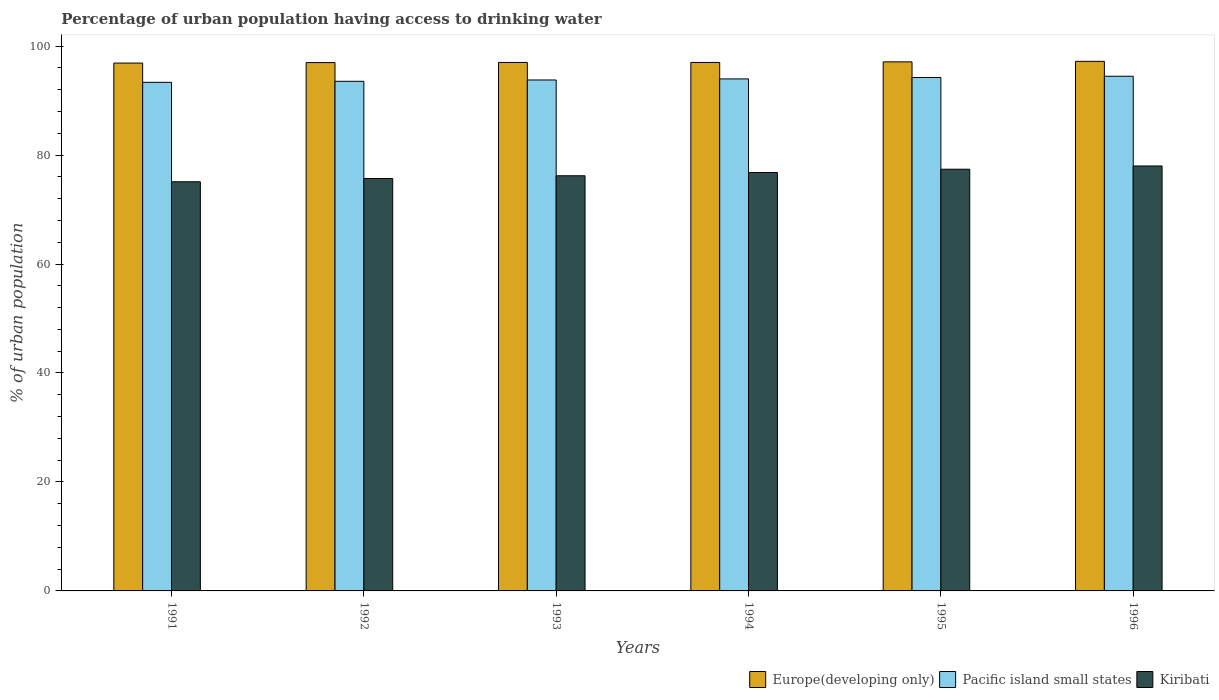How many bars are there on the 3rd tick from the left?
Give a very brief answer. 3. How many bars are there on the 1st tick from the right?
Your answer should be very brief. 3. What is the label of the 6th group of bars from the left?
Keep it short and to the point. 1996. What is the percentage of urban population having access to drinking water in Europe(developing only) in 1991?
Your response must be concise. 96.88. Across all years, what is the maximum percentage of urban population having access to drinking water in Pacific island small states?
Make the answer very short. 94.47. Across all years, what is the minimum percentage of urban population having access to drinking water in Kiribati?
Make the answer very short. 75.1. In which year was the percentage of urban population having access to drinking water in Europe(developing only) maximum?
Provide a succinct answer. 1996. What is the total percentage of urban population having access to drinking water in Europe(developing only) in the graph?
Your answer should be compact. 582.17. What is the difference between the percentage of urban population having access to drinking water in Pacific island small states in 1991 and that in 1995?
Your response must be concise. -0.89. What is the difference between the percentage of urban population having access to drinking water in Europe(developing only) in 1993 and the percentage of urban population having access to drinking water in Pacific island small states in 1994?
Ensure brevity in your answer.  3.02. What is the average percentage of urban population having access to drinking water in Europe(developing only) per year?
Provide a short and direct response. 97.03. In the year 1993, what is the difference between the percentage of urban population having access to drinking water in Kiribati and percentage of urban population having access to drinking water in Pacific island small states?
Offer a very short reply. -17.58. In how many years, is the percentage of urban population having access to drinking water in Kiribati greater than 68 %?
Your answer should be very brief. 6. What is the ratio of the percentage of urban population having access to drinking water in Kiribati in 1995 to that in 1996?
Provide a succinct answer. 0.99. Is the percentage of urban population having access to drinking water in Pacific island small states in 1991 less than that in 1992?
Your response must be concise. Yes. What is the difference between the highest and the second highest percentage of urban population having access to drinking water in Europe(developing only)?
Provide a short and direct response. 0.09. What is the difference between the highest and the lowest percentage of urban population having access to drinking water in Kiribati?
Make the answer very short. 2.9. In how many years, is the percentage of urban population having access to drinking water in Europe(developing only) greater than the average percentage of urban population having access to drinking water in Europe(developing only) taken over all years?
Give a very brief answer. 2. What does the 3rd bar from the left in 1995 represents?
Your response must be concise. Kiribati. What does the 2nd bar from the right in 1996 represents?
Offer a very short reply. Pacific island small states. Is it the case that in every year, the sum of the percentage of urban population having access to drinking water in Europe(developing only) and percentage of urban population having access to drinking water in Kiribati is greater than the percentage of urban population having access to drinking water in Pacific island small states?
Give a very brief answer. Yes. Are all the bars in the graph horizontal?
Your answer should be compact. No. How many years are there in the graph?
Give a very brief answer. 6. Are the values on the major ticks of Y-axis written in scientific E-notation?
Keep it short and to the point. No. Does the graph contain any zero values?
Your response must be concise. No. Where does the legend appear in the graph?
Your answer should be very brief. Bottom right. What is the title of the graph?
Offer a very short reply. Percentage of urban population having access to drinking water. What is the label or title of the X-axis?
Make the answer very short. Years. What is the label or title of the Y-axis?
Keep it short and to the point. % of urban population. What is the % of urban population in Europe(developing only) in 1991?
Your answer should be compact. 96.88. What is the % of urban population of Pacific island small states in 1991?
Offer a very short reply. 93.35. What is the % of urban population in Kiribati in 1991?
Provide a short and direct response. 75.1. What is the % of urban population of Europe(developing only) in 1992?
Keep it short and to the point. 96.97. What is the % of urban population of Pacific island small states in 1992?
Offer a terse response. 93.54. What is the % of urban population in Kiribati in 1992?
Offer a terse response. 75.7. What is the % of urban population of Europe(developing only) in 1993?
Your answer should be very brief. 97. What is the % of urban population in Pacific island small states in 1993?
Ensure brevity in your answer.  93.78. What is the % of urban population of Kiribati in 1993?
Offer a terse response. 76.2. What is the % of urban population of Europe(developing only) in 1994?
Offer a very short reply. 97. What is the % of urban population in Pacific island small states in 1994?
Make the answer very short. 93.98. What is the % of urban population in Kiribati in 1994?
Provide a short and direct response. 76.8. What is the % of urban population of Europe(developing only) in 1995?
Provide a succinct answer. 97.11. What is the % of urban population in Pacific island small states in 1995?
Your answer should be very brief. 94.24. What is the % of urban population of Kiribati in 1995?
Your answer should be very brief. 77.4. What is the % of urban population in Europe(developing only) in 1996?
Make the answer very short. 97.2. What is the % of urban population of Pacific island small states in 1996?
Give a very brief answer. 94.47. Across all years, what is the maximum % of urban population in Europe(developing only)?
Make the answer very short. 97.2. Across all years, what is the maximum % of urban population in Pacific island small states?
Offer a very short reply. 94.47. Across all years, what is the maximum % of urban population of Kiribati?
Make the answer very short. 78. Across all years, what is the minimum % of urban population of Europe(developing only)?
Ensure brevity in your answer.  96.88. Across all years, what is the minimum % of urban population in Pacific island small states?
Your response must be concise. 93.35. Across all years, what is the minimum % of urban population in Kiribati?
Provide a succinct answer. 75.1. What is the total % of urban population in Europe(developing only) in the graph?
Give a very brief answer. 582.17. What is the total % of urban population in Pacific island small states in the graph?
Your answer should be compact. 563.35. What is the total % of urban population of Kiribati in the graph?
Offer a very short reply. 459.2. What is the difference between the % of urban population of Europe(developing only) in 1991 and that in 1992?
Provide a succinct answer. -0.09. What is the difference between the % of urban population of Pacific island small states in 1991 and that in 1992?
Provide a succinct answer. -0.19. What is the difference between the % of urban population of Europe(developing only) in 1991 and that in 1993?
Offer a very short reply. -0.12. What is the difference between the % of urban population of Pacific island small states in 1991 and that in 1993?
Provide a succinct answer. -0.43. What is the difference between the % of urban population in Europe(developing only) in 1991 and that in 1994?
Provide a succinct answer. -0.11. What is the difference between the % of urban population in Pacific island small states in 1991 and that in 1994?
Provide a succinct answer. -0.63. What is the difference between the % of urban population in Europe(developing only) in 1991 and that in 1995?
Offer a terse response. -0.22. What is the difference between the % of urban population of Pacific island small states in 1991 and that in 1995?
Your answer should be very brief. -0.89. What is the difference between the % of urban population in Europe(developing only) in 1991 and that in 1996?
Ensure brevity in your answer.  -0.32. What is the difference between the % of urban population in Pacific island small states in 1991 and that in 1996?
Ensure brevity in your answer.  -1.12. What is the difference between the % of urban population in Europe(developing only) in 1992 and that in 1993?
Give a very brief answer. -0.03. What is the difference between the % of urban population of Pacific island small states in 1992 and that in 1993?
Your answer should be compact. -0.24. What is the difference between the % of urban population in Europe(developing only) in 1992 and that in 1994?
Give a very brief answer. -0.03. What is the difference between the % of urban population of Pacific island small states in 1992 and that in 1994?
Offer a terse response. -0.44. What is the difference between the % of urban population in Europe(developing only) in 1992 and that in 1995?
Make the answer very short. -0.14. What is the difference between the % of urban population in Pacific island small states in 1992 and that in 1995?
Your response must be concise. -0.7. What is the difference between the % of urban population of Europe(developing only) in 1992 and that in 1996?
Offer a terse response. -0.23. What is the difference between the % of urban population of Pacific island small states in 1992 and that in 1996?
Your answer should be compact. -0.93. What is the difference between the % of urban population in Kiribati in 1992 and that in 1996?
Make the answer very short. -2.3. What is the difference between the % of urban population in Europe(developing only) in 1993 and that in 1994?
Keep it short and to the point. 0. What is the difference between the % of urban population of Pacific island small states in 1993 and that in 1994?
Your response must be concise. -0.19. What is the difference between the % of urban population of Kiribati in 1993 and that in 1994?
Give a very brief answer. -0.6. What is the difference between the % of urban population of Europe(developing only) in 1993 and that in 1995?
Keep it short and to the point. -0.11. What is the difference between the % of urban population in Pacific island small states in 1993 and that in 1995?
Provide a succinct answer. -0.45. What is the difference between the % of urban population of Europe(developing only) in 1993 and that in 1996?
Your answer should be very brief. -0.2. What is the difference between the % of urban population of Pacific island small states in 1993 and that in 1996?
Offer a very short reply. -0.69. What is the difference between the % of urban population in Europe(developing only) in 1994 and that in 1995?
Provide a short and direct response. -0.11. What is the difference between the % of urban population of Pacific island small states in 1994 and that in 1995?
Make the answer very short. -0.26. What is the difference between the % of urban population of Europe(developing only) in 1994 and that in 1996?
Give a very brief answer. -0.2. What is the difference between the % of urban population in Pacific island small states in 1994 and that in 1996?
Provide a succinct answer. -0.49. What is the difference between the % of urban population of Europe(developing only) in 1995 and that in 1996?
Ensure brevity in your answer.  -0.09. What is the difference between the % of urban population in Pacific island small states in 1995 and that in 1996?
Your answer should be compact. -0.23. What is the difference between the % of urban population in Kiribati in 1995 and that in 1996?
Provide a succinct answer. -0.6. What is the difference between the % of urban population of Europe(developing only) in 1991 and the % of urban population of Pacific island small states in 1992?
Keep it short and to the point. 3.35. What is the difference between the % of urban population in Europe(developing only) in 1991 and the % of urban population in Kiribati in 1992?
Your answer should be compact. 21.18. What is the difference between the % of urban population in Pacific island small states in 1991 and the % of urban population in Kiribati in 1992?
Ensure brevity in your answer.  17.65. What is the difference between the % of urban population in Europe(developing only) in 1991 and the % of urban population in Pacific island small states in 1993?
Offer a terse response. 3.1. What is the difference between the % of urban population in Europe(developing only) in 1991 and the % of urban population in Kiribati in 1993?
Keep it short and to the point. 20.68. What is the difference between the % of urban population in Pacific island small states in 1991 and the % of urban population in Kiribati in 1993?
Ensure brevity in your answer.  17.15. What is the difference between the % of urban population of Europe(developing only) in 1991 and the % of urban population of Pacific island small states in 1994?
Keep it short and to the point. 2.91. What is the difference between the % of urban population in Europe(developing only) in 1991 and the % of urban population in Kiribati in 1994?
Ensure brevity in your answer.  20.08. What is the difference between the % of urban population of Pacific island small states in 1991 and the % of urban population of Kiribati in 1994?
Ensure brevity in your answer.  16.55. What is the difference between the % of urban population of Europe(developing only) in 1991 and the % of urban population of Pacific island small states in 1995?
Make the answer very short. 2.65. What is the difference between the % of urban population in Europe(developing only) in 1991 and the % of urban population in Kiribati in 1995?
Give a very brief answer. 19.48. What is the difference between the % of urban population in Pacific island small states in 1991 and the % of urban population in Kiribati in 1995?
Ensure brevity in your answer.  15.95. What is the difference between the % of urban population of Europe(developing only) in 1991 and the % of urban population of Pacific island small states in 1996?
Provide a succinct answer. 2.42. What is the difference between the % of urban population of Europe(developing only) in 1991 and the % of urban population of Kiribati in 1996?
Keep it short and to the point. 18.88. What is the difference between the % of urban population of Pacific island small states in 1991 and the % of urban population of Kiribati in 1996?
Ensure brevity in your answer.  15.35. What is the difference between the % of urban population in Europe(developing only) in 1992 and the % of urban population in Pacific island small states in 1993?
Your response must be concise. 3.19. What is the difference between the % of urban population in Europe(developing only) in 1992 and the % of urban population in Kiribati in 1993?
Your answer should be compact. 20.77. What is the difference between the % of urban population of Pacific island small states in 1992 and the % of urban population of Kiribati in 1993?
Provide a succinct answer. 17.34. What is the difference between the % of urban population of Europe(developing only) in 1992 and the % of urban population of Pacific island small states in 1994?
Give a very brief answer. 3. What is the difference between the % of urban population in Europe(developing only) in 1992 and the % of urban population in Kiribati in 1994?
Your answer should be very brief. 20.17. What is the difference between the % of urban population of Pacific island small states in 1992 and the % of urban population of Kiribati in 1994?
Provide a succinct answer. 16.74. What is the difference between the % of urban population of Europe(developing only) in 1992 and the % of urban population of Pacific island small states in 1995?
Keep it short and to the point. 2.74. What is the difference between the % of urban population of Europe(developing only) in 1992 and the % of urban population of Kiribati in 1995?
Provide a short and direct response. 19.57. What is the difference between the % of urban population of Pacific island small states in 1992 and the % of urban population of Kiribati in 1995?
Your response must be concise. 16.14. What is the difference between the % of urban population in Europe(developing only) in 1992 and the % of urban population in Pacific island small states in 1996?
Make the answer very short. 2.51. What is the difference between the % of urban population in Europe(developing only) in 1992 and the % of urban population in Kiribati in 1996?
Your response must be concise. 18.97. What is the difference between the % of urban population in Pacific island small states in 1992 and the % of urban population in Kiribati in 1996?
Give a very brief answer. 15.54. What is the difference between the % of urban population in Europe(developing only) in 1993 and the % of urban population in Pacific island small states in 1994?
Offer a very short reply. 3.02. What is the difference between the % of urban population in Europe(developing only) in 1993 and the % of urban population in Kiribati in 1994?
Your response must be concise. 20.2. What is the difference between the % of urban population of Pacific island small states in 1993 and the % of urban population of Kiribati in 1994?
Provide a succinct answer. 16.98. What is the difference between the % of urban population in Europe(developing only) in 1993 and the % of urban population in Pacific island small states in 1995?
Your answer should be compact. 2.76. What is the difference between the % of urban population of Europe(developing only) in 1993 and the % of urban population of Kiribati in 1995?
Your answer should be very brief. 19.6. What is the difference between the % of urban population in Pacific island small states in 1993 and the % of urban population in Kiribati in 1995?
Your answer should be very brief. 16.38. What is the difference between the % of urban population in Europe(developing only) in 1993 and the % of urban population in Pacific island small states in 1996?
Your response must be concise. 2.53. What is the difference between the % of urban population in Europe(developing only) in 1993 and the % of urban population in Kiribati in 1996?
Make the answer very short. 19. What is the difference between the % of urban population in Pacific island small states in 1993 and the % of urban population in Kiribati in 1996?
Your answer should be very brief. 15.78. What is the difference between the % of urban population in Europe(developing only) in 1994 and the % of urban population in Pacific island small states in 1995?
Your response must be concise. 2.76. What is the difference between the % of urban population of Europe(developing only) in 1994 and the % of urban population of Kiribati in 1995?
Your answer should be compact. 19.6. What is the difference between the % of urban population in Pacific island small states in 1994 and the % of urban population in Kiribati in 1995?
Your response must be concise. 16.58. What is the difference between the % of urban population in Europe(developing only) in 1994 and the % of urban population in Pacific island small states in 1996?
Your answer should be very brief. 2.53. What is the difference between the % of urban population of Europe(developing only) in 1994 and the % of urban population of Kiribati in 1996?
Ensure brevity in your answer.  19. What is the difference between the % of urban population in Pacific island small states in 1994 and the % of urban population in Kiribati in 1996?
Offer a very short reply. 15.98. What is the difference between the % of urban population of Europe(developing only) in 1995 and the % of urban population of Pacific island small states in 1996?
Your answer should be compact. 2.64. What is the difference between the % of urban population of Europe(developing only) in 1995 and the % of urban population of Kiribati in 1996?
Provide a short and direct response. 19.11. What is the difference between the % of urban population of Pacific island small states in 1995 and the % of urban population of Kiribati in 1996?
Make the answer very short. 16.24. What is the average % of urban population of Europe(developing only) per year?
Make the answer very short. 97.03. What is the average % of urban population in Pacific island small states per year?
Your response must be concise. 93.89. What is the average % of urban population of Kiribati per year?
Offer a terse response. 76.53. In the year 1991, what is the difference between the % of urban population in Europe(developing only) and % of urban population in Pacific island small states?
Your answer should be very brief. 3.53. In the year 1991, what is the difference between the % of urban population in Europe(developing only) and % of urban population in Kiribati?
Your response must be concise. 21.78. In the year 1991, what is the difference between the % of urban population in Pacific island small states and % of urban population in Kiribati?
Your answer should be compact. 18.25. In the year 1992, what is the difference between the % of urban population of Europe(developing only) and % of urban population of Pacific island small states?
Provide a succinct answer. 3.43. In the year 1992, what is the difference between the % of urban population in Europe(developing only) and % of urban population in Kiribati?
Your answer should be compact. 21.27. In the year 1992, what is the difference between the % of urban population of Pacific island small states and % of urban population of Kiribati?
Give a very brief answer. 17.84. In the year 1993, what is the difference between the % of urban population of Europe(developing only) and % of urban population of Pacific island small states?
Offer a terse response. 3.22. In the year 1993, what is the difference between the % of urban population in Europe(developing only) and % of urban population in Kiribati?
Make the answer very short. 20.8. In the year 1993, what is the difference between the % of urban population of Pacific island small states and % of urban population of Kiribati?
Offer a terse response. 17.58. In the year 1994, what is the difference between the % of urban population of Europe(developing only) and % of urban population of Pacific island small states?
Offer a terse response. 3.02. In the year 1994, what is the difference between the % of urban population of Europe(developing only) and % of urban population of Kiribati?
Give a very brief answer. 20.2. In the year 1994, what is the difference between the % of urban population of Pacific island small states and % of urban population of Kiribati?
Your answer should be compact. 17.18. In the year 1995, what is the difference between the % of urban population in Europe(developing only) and % of urban population in Pacific island small states?
Give a very brief answer. 2.87. In the year 1995, what is the difference between the % of urban population in Europe(developing only) and % of urban population in Kiribati?
Make the answer very short. 19.71. In the year 1995, what is the difference between the % of urban population in Pacific island small states and % of urban population in Kiribati?
Offer a very short reply. 16.84. In the year 1996, what is the difference between the % of urban population of Europe(developing only) and % of urban population of Pacific island small states?
Ensure brevity in your answer.  2.73. In the year 1996, what is the difference between the % of urban population of Europe(developing only) and % of urban population of Kiribati?
Provide a succinct answer. 19.2. In the year 1996, what is the difference between the % of urban population of Pacific island small states and % of urban population of Kiribati?
Provide a succinct answer. 16.47. What is the ratio of the % of urban population in Pacific island small states in 1991 to that in 1993?
Ensure brevity in your answer.  1. What is the ratio of the % of urban population of Kiribati in 1991 to that in 1993?
Offer a very short reply. 0.99. What is the ratio of the % of urban population in Europe(developing only) in 1991 to that in 1994?
Ensure brevity in your answer.  1. What is the ratio of the % of urban population in Kiribati in 1991 to that in 1994?
Keep it short and to the point. 0.98. What is the ratio of the % of urban population in Europe(developing only) in 1991 to that in 1995?
Keep it short and to the point. 1. What is the ratio of the % of urban population in Pacific island small states in 1991 to that in 1995?
Your answer should be very brief. 0.99. What is the ratio of the % of urban population in Kiribati in 1991 to that in 1995?
Your answer should be very brief. 0.97. What is the ratio of the % of urban population of Europe(developing only) in 1991 to that in 1996?
Provide a succinct answer. 1. What is the ratio of the % of urban population of Kiribati in 1991 to that in 1996?
Provide a succinct answer. 0.96. What is the ratio of the % of urban population in Europe(developing only) in 1992 to that in 1993?
Your answer should be compact. 1. What is the ratio of the % of urban population of Kiribati in 1992 to that in 1993?
Provide a succinct answer. 0.99. What is the ratio of the % of urban population of Pacific island small states in 1992 to that in 1994?
Keep it short and to the point. 1. What is the ratio of the % of urban population of Kiribati in 1992 to that in 1994?
Keep it short and to the point. 0.99. What is the ratio of the % of urban population in Europe(developing only) in 1992 to that in 1996?
Provide a short and direct response. 1. What is the ratio of the % of urban population in Pacific island small states in 1992 to that in 1996?
Offer a terse response. 0.99. What is the ratio of the % of urban population of Kiribati in 1992 to that in 1996?
Give a very brief answer. 0.97. What is the ratio of the % of urban population in Kiribati in 1993 to that in 1994?
Give a very brief answer. 0.99. What is the ratio of the % of urban population of Europe(developing only) in 1993 to that in 1995?
Your answer should be compact. 1. What is the ratio of the % of urban population of Kiribati in 1993 to that in 1995?
Make the answer very short. 0.98. What is the ratio of the % of urban population of Europe(developing only) in 1993 to that in 1996?
Keep it short and to the point. 1. What is the ratio of the % of urban population of Kiribati in 1993 to that in 1996?
Keep it short and to the point. 0.98. What is the ratio of the % of urban population of Pacific island small states in 1994 to that in 1995?
Keep it short and to the point. 1. What is the ratio of the % of urban population in Kiribati in 1994 to that in 1996?
Your answer should be very brief. 0.98. What is the ratio of the % of urban population of Europe(developing only) in 1995 to that in 1996?
Give a very brief answer. 1. What is the ratio of the % of urban population of Kiribati in 1995 to that in 1996?
Your answer should be very brief. 0.99. What is the difference between the highest and the second highest % of urban population in Europe(developing only)?
Provide a short and direct response. 0.09. What is the difference between the highest and the second highest % of urban population in Pacific island small states?
Provide a succinct answer. 0.23. What is the difference between the highest and the lowest % of urban population of Europe(developing only)?
Provide a succinct answer. 0.32. What is the difference between the highest and the lowest % of urban population in Pacific island small states?
Your answer should be compact. 1.12. 